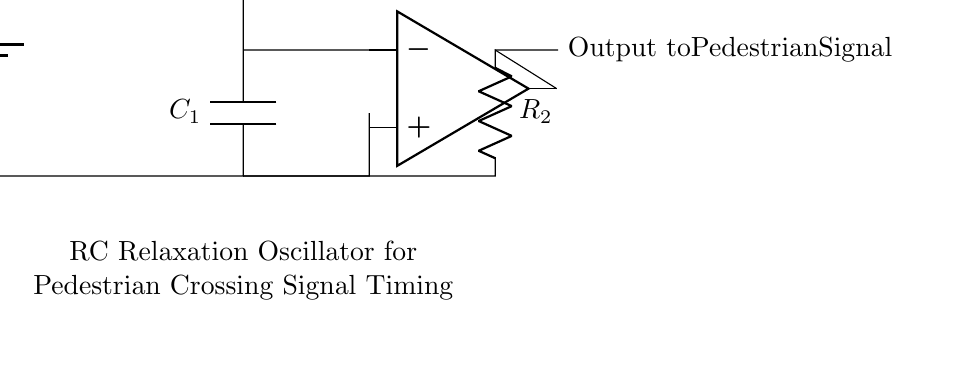What is the power supply voltage? The power supply voltage is labeled as Vcc in the circuit diagram, which typically refers to the positive supply voltage for the components. Since there is no specific value given in the provided data, we refer to it as Vcc.
Answer: Vcc What component is connected to the output of the op-amp? The output of the op-amp is connected to a resistor labeled as R2, which brings the output signal to the pedestrian crossing signal.
Answer: R2 What is the function of capacitor C1 in this circuit? The capacitor C1 plays a critical role in the timing aspect of the RC relaxation oscillator, as it charges and discharges to create the oscillation needed for the signal timing.
Answer: Timing How does R1 affect the frequency of oscillation? The resistor R1 directly influences the time constant of the circuit in conjunction with capacitor C1. The larger the resistance, the longer it takes for C1 to charge and discharge, thus decreasing the frequency of oscillation.
Answer: Decreases frequency What is the main purpose of the RC relaxation oscillator in this setup? The main purpose of the RC relaxation oscillator is to generate a timing signal for the pedestrian crossing signal, allowing safe crossing intervals for pedestrians.
Answer: Timing signal What happens when C1 fully discharges? When C1 fully discharges, the voltage across it drops to zero, causing the output of the op-amp to switch states and initiate the charging cycle again, creating a repeating oscillation.
Answer: Switch states 